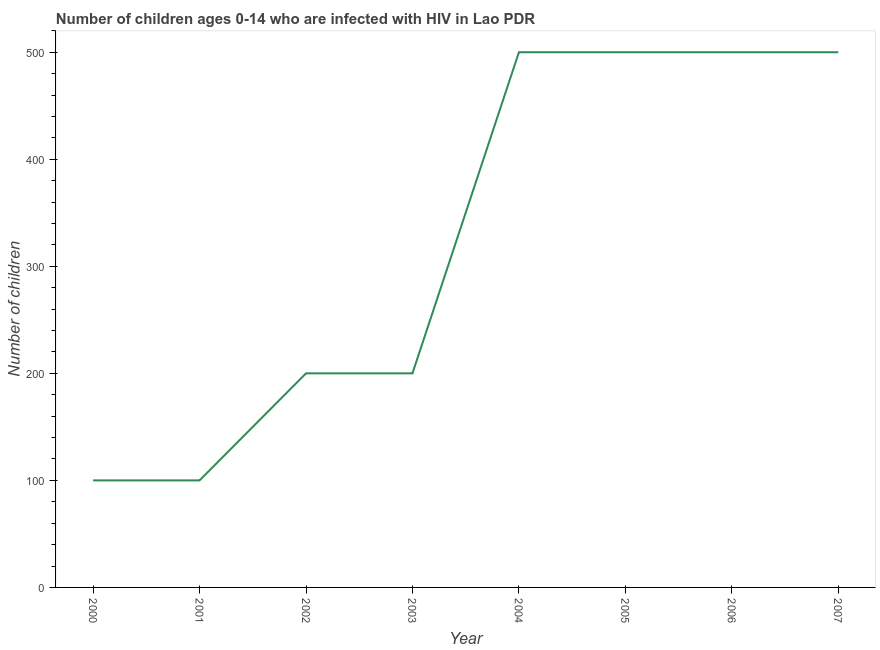What is the number of children living with hiv in 2003?
Offer a terse response. 200. Across all years, what is the maximum number of children living with hiv?
Give a very brief answer. 500. Across all years, what is the minimum number of children living with hiv?
Your answer should be very brief. 100. In which year was the number of children living with hiv maximum?
Offer a very short reply. 2004. What is the sum of the number of children living with hiv?
Keep it short and to the point. 2600. What is the difference between the number of children living with hiv in 2000 and 2004?
Your response must be concise. -400. What is the average number of children living with hiv per year?
Offer a terse response. 325. What is the median number of children living with hiv?
Your answer should be very brief. 350. In how many years, is the number of children living with hiv greater than 300 ?
Your answer should be very brief. 4. What is the ratio of the number of children living with hiv in 2006 to that in 2007?
Offer a terse response. 1. What is the difference between the highest and the second highest number of children living with hiv?
Your answer should be compact. 0. Is the sum of the number of children living with hiv in 2000 and 2004 greater than the maximum number of children living with hiv across all years?
Keep it short and to the point. Yes. What is the difference between the highest and the lowest number of children living with hiv?
Your answer should be compact. 400. In how many years, is the number of children living with hiv greater than the average number of children living with hiv taken over all years?
Your answer should be very brief. 4. Does the number of children living with hiv monotonically increase over the years?
Keep it short and to the point. No. How many years are there in the graph?
Provide a short and direct response. 8. Does the graph contain grids?
Your response must be concise. No. What is the title of the graph?
Your response must be concise. Number of children ages 0-14 who are infected with HIV in Lao PDR. What is the label or title of the X-axis?
Keep it short and to the point. Year. What is the label or title of the Y-axis?
Provide a short and direct response. Number of children. What is the Number of children in 2000?
Make the answer very short. 100. What is the Number of children in 2001?
Provide a succinct answer. 100. What is the Number of children in 2005?
Your answer should be compact. 500. What is the difference between the Number of children in 2000 and 2001?
Keep it short and to the point. 0. What is the difference between the Number of children in 2000 and 2002?
Your answer should be compact. -100. What is the difference between the Number of children in 2000 and 2003?
Offer a terse response. -100. What is the difference between the Number of children in 2000 and 2004?
Make the answer very short. -400. What is the difference between the Number of children in 2000 and 2005?
Provide a short and direct response. -400. What is the difference between the Number of children in 2000 and 2006?
Your answer should be very brief. -400. What is the difference between the Number of children in 2000 and 2007?
Provide a short and direct response. -400. What is the difference between the Number of children in 2001 and 2002?
Give a very brief answer. -100. What is the difference between the Number of children in 2001 and 2003?
Give a very brief answer. -100. What is the difference between the Number of children in 2001 and 2004?
Provide a short and direct response. -400. What is the difference between the Number of children in 2001 and 2005?
Ensure brevity in your answer.  -400. What is the difference between the Number of children in 2001 and 2006?
Make the answer very short. -400. What is the difference between the Number of children in 2001 and 2007?
Your answer should be compact. -400. What is the difference between the Number of children in 2002 and 2003?
Ensure brevity in your answer.  0. What is the difference between the Number of children in 2002 and 2004?
Make the answer very short. -300. What is the difference between the Number of children in 2002 and 2005?
Keep it short and to the point. -300. What is the difference between the Number of children in 2002 and 2006?
Your response must be concise. -300. What is the difference between the Number of children in 2002 and 2007?
Ensure brevity in your answer.  -300. What is the difference between the Number of children in 2003 and 2004?
Give a very brief answer. -300. What is the difference between the Number of children in 2003 and 2005?
Your response must be concise. -300. What is the difference between the Number of children in 2003 and 2006?
Offer a very short reply. -300. What is the difference between the Number of children in 2003 and 2007?
Keep it short and to the point. -300. What is the difference between the Number of children in 2004 and 2007?
Provide a short and direct response. 0. What is the ratio of the Number of children in 2000 to that in 2003?
Offer a very short reply. 0.5. What is the ratio of the Number of children in 2000 to that in 2004?
Provide a succinct answer. 0.2. What is the ratio of the Number of children in 2000 to that in 2005?
Your answer should be very brief. 0.2. What is the ratio of the Number of children in 2000 to that in 2006?
Give a very brief answer. 0.2. What is the ratio of the Number of children in 2000 to that in 2007?
Provide a succinct answer. 0.2. What is the ratio of the Number of children in 2001 to that in 2002?
Your response must be concise. 0.5. What is the ratio of the Number of children in 2001 to that in 2003?
Provide a succinct answer. 0.5. What is the ratio of the Number of children in 2001 to that in 2005?
Ensure brevity in your answer.  0.2. What is the ratio of the Number of children in 2001 to that in 2006?
Provide a short and direct response. 0.2. What is the ratio of the Number of children in 2002 to that in 2003?
Give a very brief answer. 1. What is the ratio of the Number of children in 2002 to that in 2004?
Provide a short and direct response. 0.4. What is the ratio of the Number of children in 2002 to that in 2006?
Ensure brevity in your answer.  0.4. What is the ratio of the Number of children in 2002 to that in 2007?
Offer a terse response. 0.4. What is the ratio of the Number of children in 2003 to that in 2006?
Provide a succinct answer. 0.4. What is the ratio of the Number of children in 2003 to that in 2007?
Ensure brevity in your answer.  0.4. What is the ratio of the Number of children in 2004 to that in 2005?
Offer a very short reply. 1. What is the ratio of the Number of children in 2004 to that in 2007?
Offer a very short reply. 1. What is the ratio of the Number of children in 2005 to that in 2006?
Your response must be concise. 1. What is the ratio of the Number of children in 2005 to that in 2007?
Offer a very short reply. 1. 